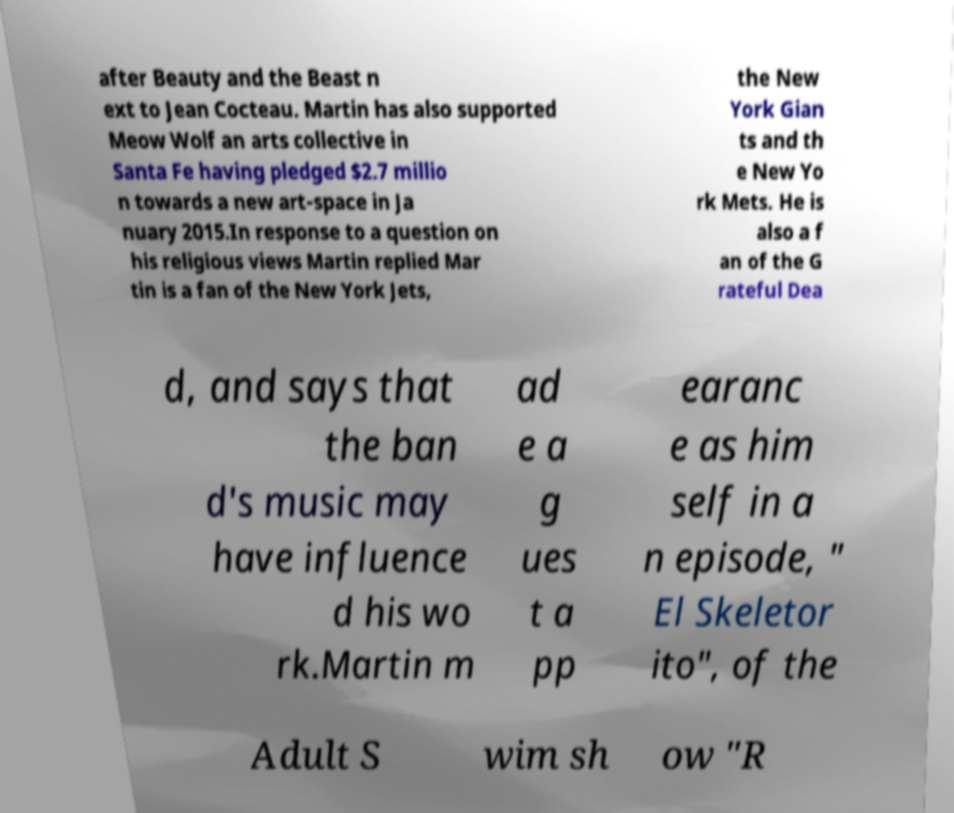Can you accurately transcribe the text from the provided image for me? after Beauty and the Beast n ext to Jean Cocteau. Martin has also supported Meow Wolf an arts collective in Santa Fe having pledged $2.7 millio n towards a new art-space in Ja nuary 2015.In response to a question on his religious views Martin replied Mar tin is a fan of the New York Jets, the New York Gian ts and th e New Yo rk Mets. He is also a f an of the G rateful Dea d, and says that the ban d's music may have influence d his wo rk.Martin m ad e a g ues t a pp earanc e as him self in a n episode, " El Skeletor ito", of the Adult S wim sh ow "R 